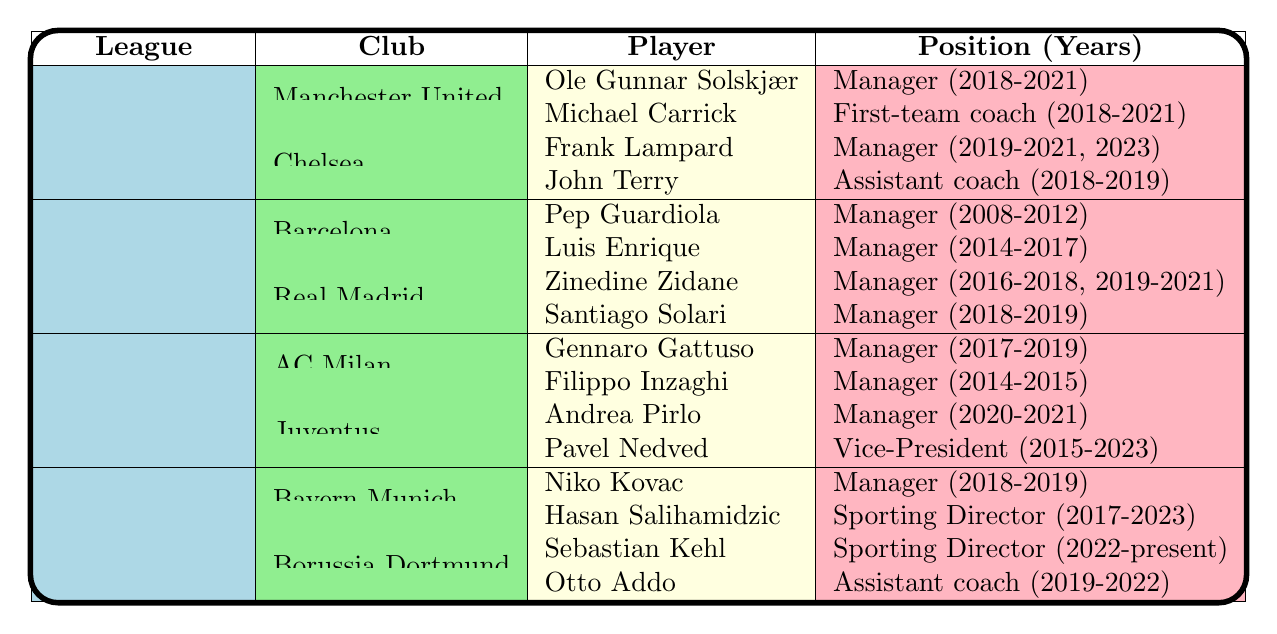What league did Ole Gunnar Solskjær manage in? Looking at the table, Ole Gunnar Solskjær is listed under the "Manchester United" club and "Premier League" league, where he served as Manager.
Answer: Premier League Which player has the longest managerial tenure in La Liga? In La Liga, Zinedine Zidane served as Manager for two periods: 2016-2018 and 2019-2021, totaling five years. The other managers listed have shorter tenures (Pep Guardiola for 4 years, Luis Enrique for 3 years, and Santiago Solari for 1 year).
Answer: Zinedine Zidane Did Frank Lampard coach Chelsea in 2022? The table lists Frank Lampard's managerial tenure at Chelsea as 2019-2021 and 2023, which does not include the year 2022. Therefore, he did not coach Chelsea in that year.
Answer: No How many players from Juventus hold managerial positions? The table indicates that Andrea Pirlo held the position of Manager for 2020-2021 and Pavel Nedved served as Vice-President from 2015-2023. There are two players, but only one was a manager.
Answer: One Which club had the most diverse positions held by retired players according to the table? Analyzing the table, Chelsea has two distinct positions (Manager and Assistant Coach) held by Frank Lampard and John Terry, respectively. In contrast, most other clubs either have only managerial positions or one additional role.
Answer: Chelsea How many years did Gennaro Gattuso manage AC Milan? The table specifies that Gennaro Gattuso was the Manager of AC Milan from 2017 to 2019, which is a total of 2 years.
Answer: 2 years Which player has served in a front-office position in Serie A? The table mentions Pavel Nedved as the Vice-President of Juventus from 2015 to 2023, which is a front-office position, while others listed served only as managers.
Answer: Pavel Nedved Which league features the most instances of the manager's position according to the table? By reviewing the table, each league has several managers listed, but La Liga has four instances of managers (Pep Guardiola, Luis Enrique, Zinedine Zidane, and Santiago Solari), which is higher than others.
Answer: La Liga What is the combined number of years that Zinedine Zidane managed Real Madrid? The table states that Zidane managed from 2016-2018 (2 years) and then again from 2019-2021 (2 years), leading to a total of 4 years of management at Real Madrid.
Answer: 4 years Is Hasan Salihamidzic currently holding his position at Bayern Munich? The table shows that Hasan Salihamidzic has been the Sporting Director at Bayern Munich from 2017 to 2023. Since the status is "present," he is still in that position.
Answer: Yes 